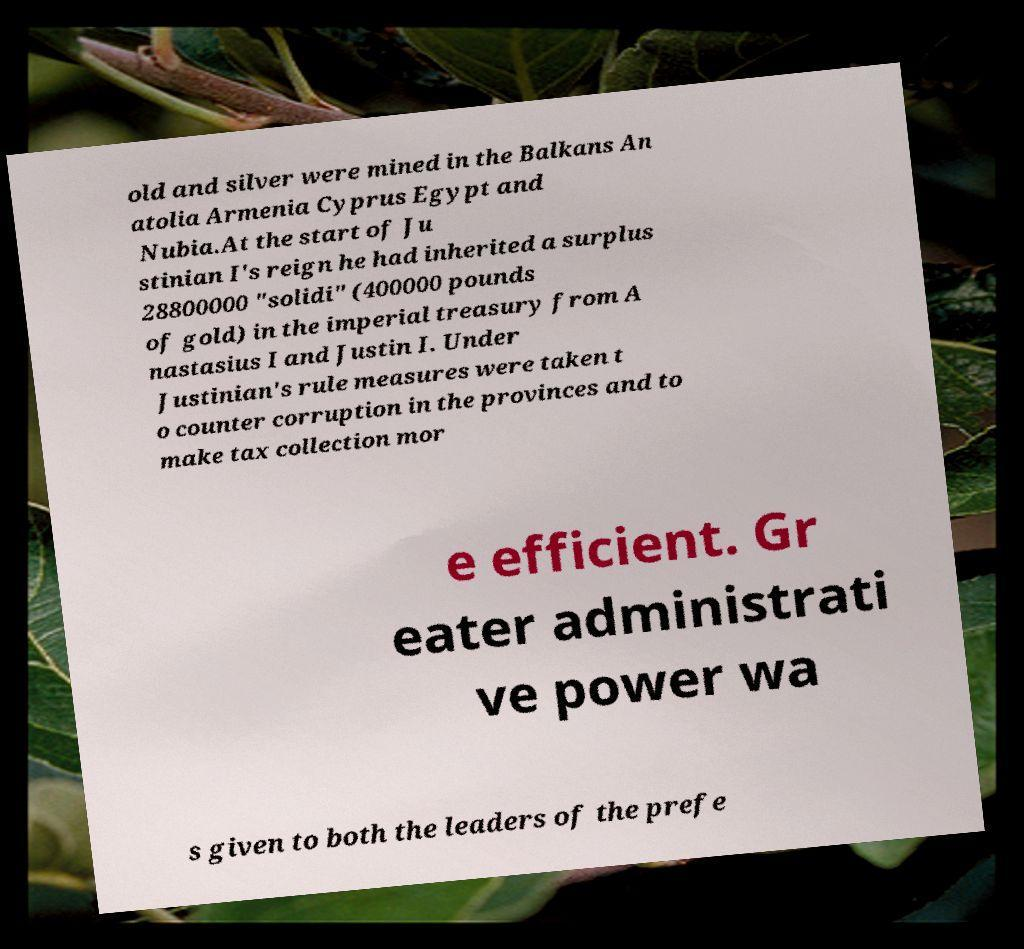Can you accurately transcribe the text from the provided image for me? old and silver were mined in the Balkans An atolia Armenia Cyprus Egypt and Nubia.At the start of Ju stinian I's reign he had inherited a surplus 28800000 "solidi" (400000 pounds of gold) in the imperial treasury from A nastasius I and Justin I. Under Justinian's rule measures were taken t o counter corruption in the provinces and to make tax collection mor e efficient. Gr eater administrati ve power wa s given to both the leaders of the prefe 